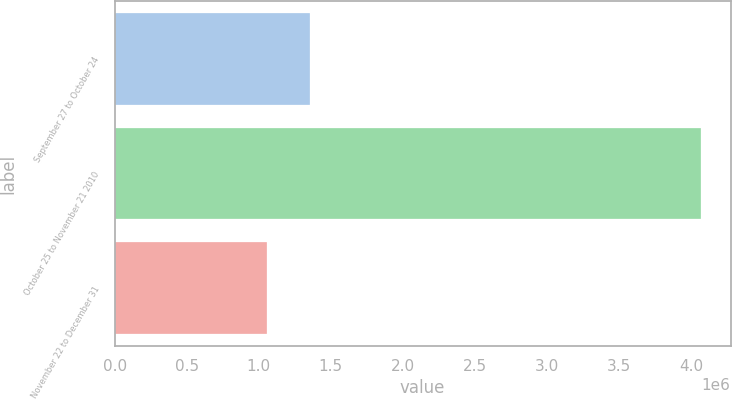<chart> <loc_0><loc_0><loc_500><loc_500><bar_chart><fcel>September 27 to October 24<fcel>October 25 to November 21 2010<fcel>November 22 to December 31<nl><fcel>1.35704e+06<fcel>4.07026e+06<fcel>1.05558e+06<nl></chart> 